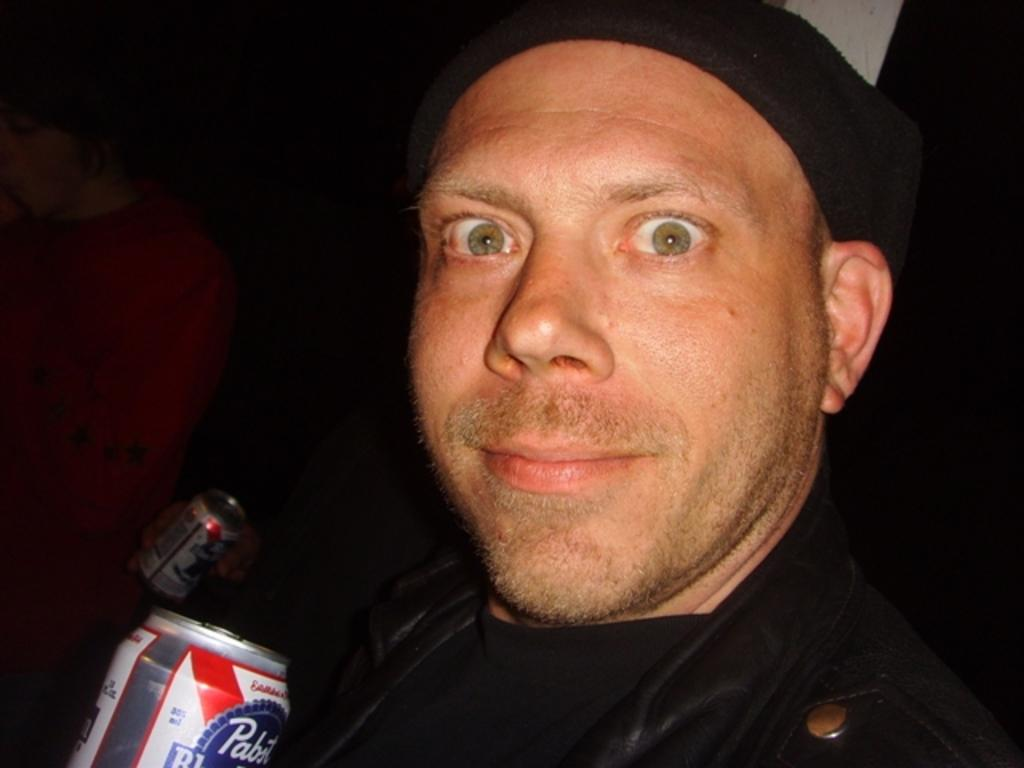What is the man in the image wearing? The man is wearing a black jacket. What is the man holding in the image? The man is holding a cool drink tin. Can you describe the other person in the image? The other person is wearing a red dress. What is the other person holding in the image? The other person is holding a tin. What type of pan can be seen in the image? There is no pan present in the image. Is the dog in the image made of copper? There is no dog present in the image, so it cannot be made of copper. 